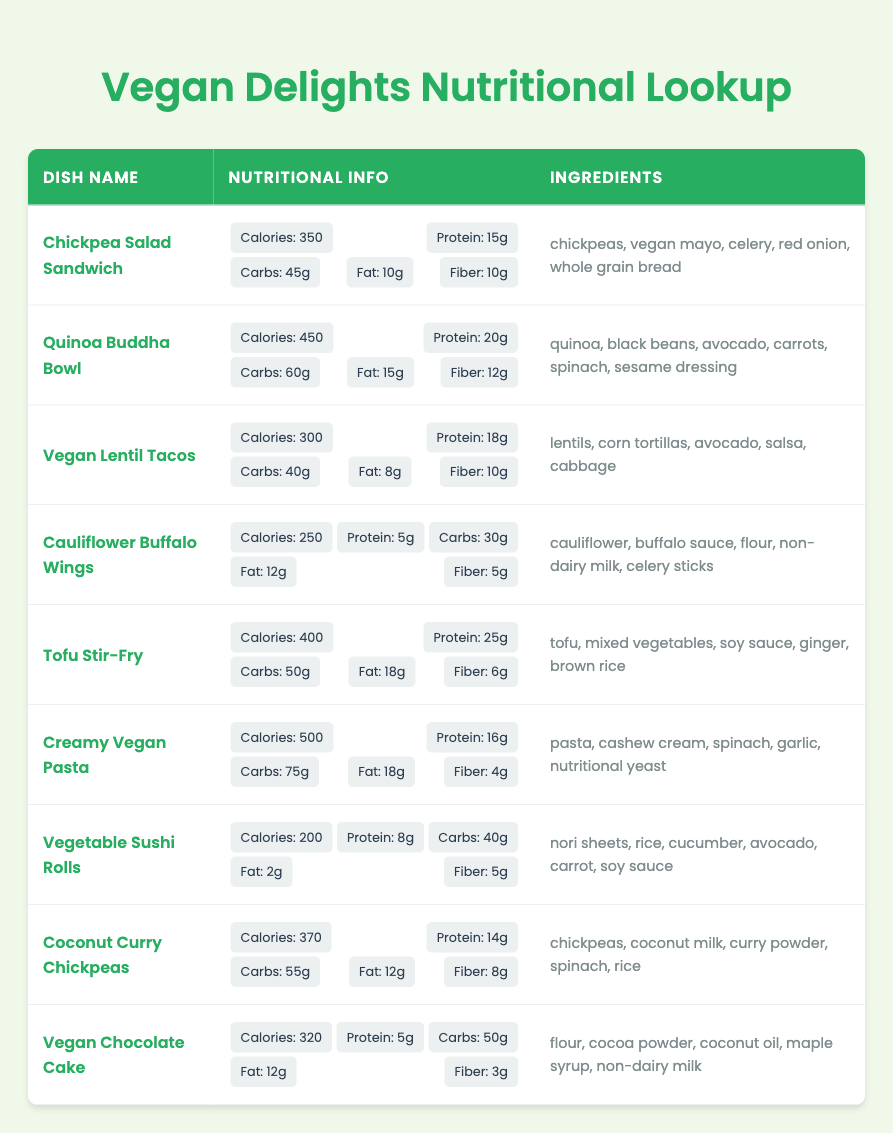What is the total calorie count for the Chickpea Salad Sandwich and Vegan Lentil Tacos? The calorie count for the Chickpea Salad Sandwich is 350, and for the Vegan Lentil Tacos, it is 300. Adding these two values gives 350 + 300 = 650.
Answer: 650 Which dish has the highest protein content? The Tofu Stir-Fry has the highest protein content at 25 grams. It is important to compare the protein values of all dishes, and Tofu Stir-Fry ranks highest among them.
Answer: Tofu Stir-Fry Is the Vegan Chocolate Cake higher in calories than the Cauliflower Buffalo Wings? The Vegan Chocolate Cake has 320 calories, while the Cauliflower Buffalo Wings have 250 calories. Since 320 is greater than 250, the statement is true.
Answer: Yes What is the average carbohydrate content of all dishes listed? To find the average, we first sum the carbohydrate values: (45 + 60 + 40 + 30 + 50 + 75 + 40 + 55 + 40 + 50) = 485. There are 10 dishes, so the average is 485/10 = 48.5.
Answer: 48.5 How many dishes have a fiber content greater than 10 grams? The dishes with fiber greater than 10 grams are the Chickpea Salad Sandwich (10g), Quinoa Buddha Bowl (12g), Vegan Lentil Tacos (10g), and Coconut Curry Chickpeas (8g). Therefore, there are 3 dishes (Chickpea Salad is exactly 10).
Answer: 3 